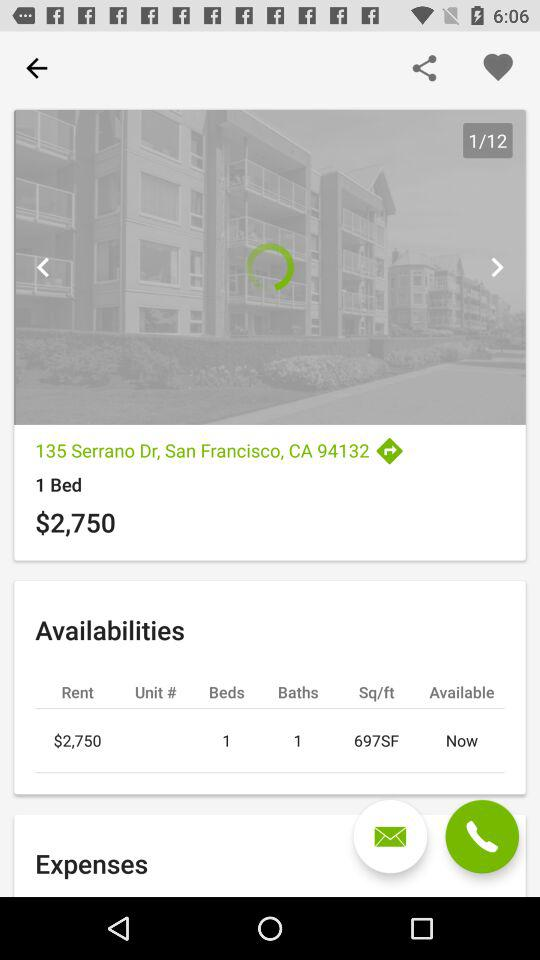What is the area of the room? The area of the room is 697 SF. 